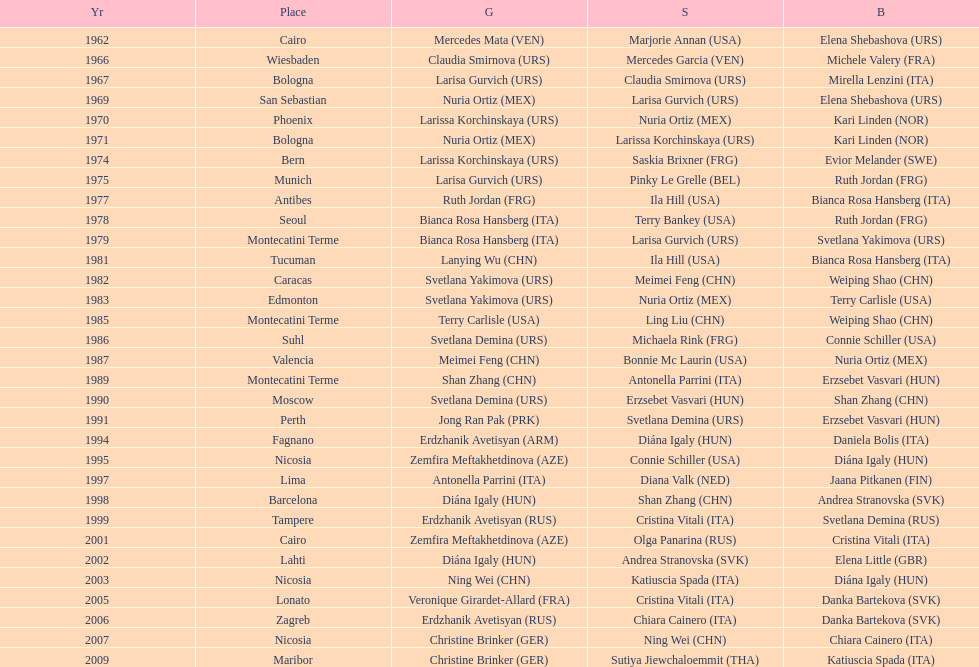Which nation possesses the highest number of bronze medals? Italy. 